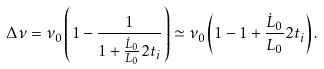<formula> <loc_0><loc_0><loc_500><loc_500>\Delta \nu = \nu _ { 0 } \left ( 1 - \frac { 1 } { 1 + \frac { \dot { L } _ { 0 } } { L _ { 0 } } 2 t _ { i } } \right ) \simeq \nu _ { 0 } \left ( 1 - 1 + \frac { \dot { L } _ { 0 } } { L _ { 0 } } 2 t _ { i } \right ) .</formula> 